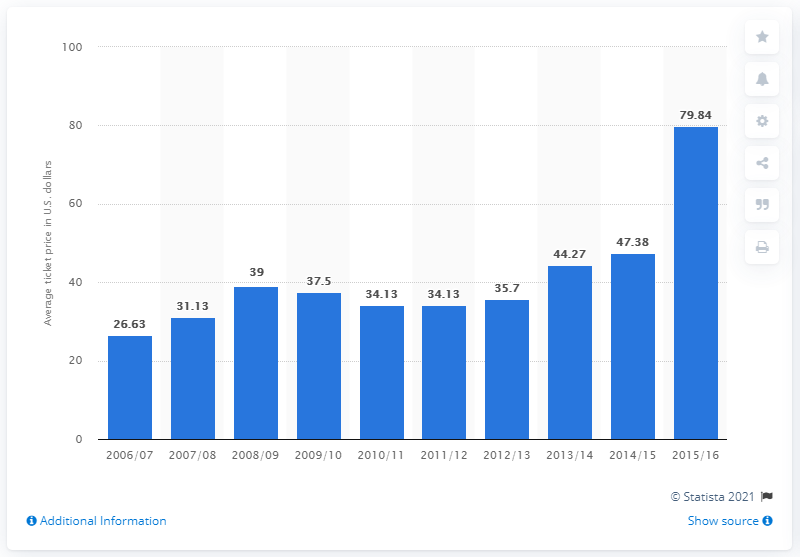Specify some key components in this picture. According to data from the 2006/2007 Golden State Warriors season, the average ticket price for their games was 26.63 dollars. 